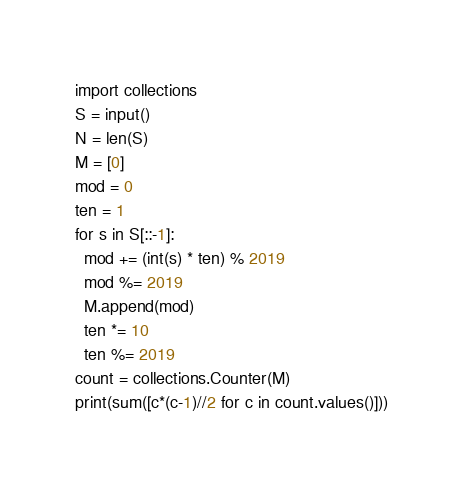<code> <loc_0><loc_0><loc_500><loc_500><_Python_>import collections
S = input()
N = len(S)
M = [0]
mod = 0
ten = 1
for s in S[::-1]:
  mod += (int(s) * ten) % 2019
  mod %= 2019
  M.append(mod)
  ten *= 10
  ten %= 2019 
count = collections.Counter(M)
print(sum([c*(c-1)//2 for c in count.values()]))</code> 